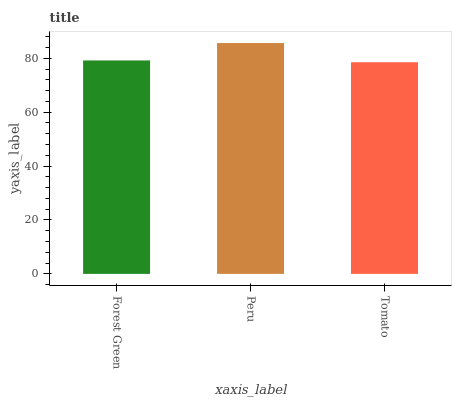Is Peru the minimum?
Answer yes or no. No. Is Tomato the maximum?
Answer yes or no. No. Is Peru greater than Tomato?
Answer yes or no. Yes. Is Tomato less than Peru?
Answer yes or no. Yes. Is Tomato greater than Peru?
Answer yes or no. No. Is Peru less than Tomato?
Answer yes or no. No. Is Forest Green the high median?
Answer yes or no. Yes. Is Forest Green the low median?
Answer yes or no. Yes. Is Peru the high median?
Answer yes or no. No. Is Peru the low median?
Answer yes or no. No. 